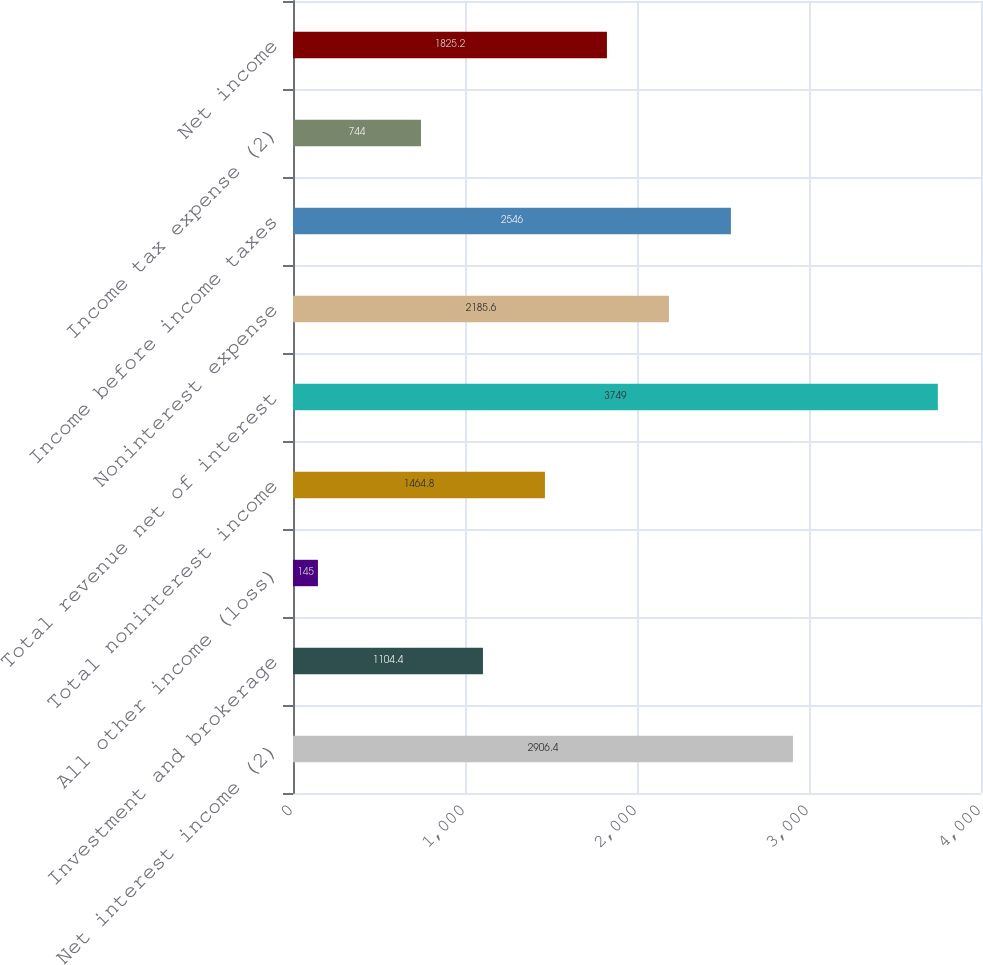<chart> <loc_0><loc_0><loc_500><loc_500><bar_chart><fcel>Net interest income (2)<fcel>Investment and brokerage<fcel>All other income (loss)<fcel>Total noninterest income<fcel>Total revenue net of interest<fcel>Noninterest expense<fcel>Income before income taxes<fcel>Income tax expense (2)<fcel>Net income<nl><fcel>2906.4<fcel>1104.4<fcel>145<fcel>1464.8<fcel>3749<fcel>2185.6<fcel>2546<fcel>744<fcel>1825.2<nl></chart> 